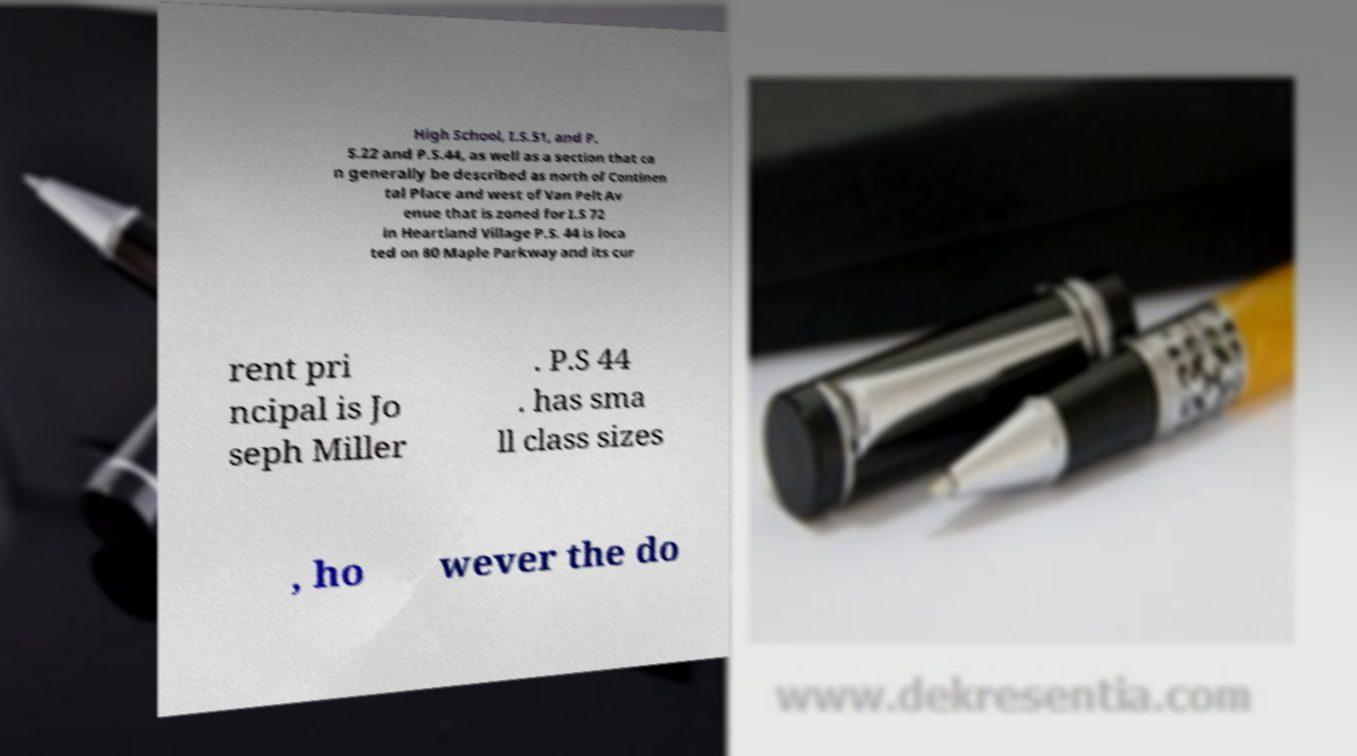I need the written content from this picture converted into text. Can you do that? High School, I.S.51, and P. S.22 and P.S.44, as well as a section that ca n generally be described as north of Continen tal Place and west of Van Pelt Av enue that is zoned for I.S 72 in Heartland Village P.S. 44 is loca ted on 80 Maple Parkway and its cur rent pri ncipal is Jo seph Miller . P.S 44 . has sma ll class sizes , ho wever the do 